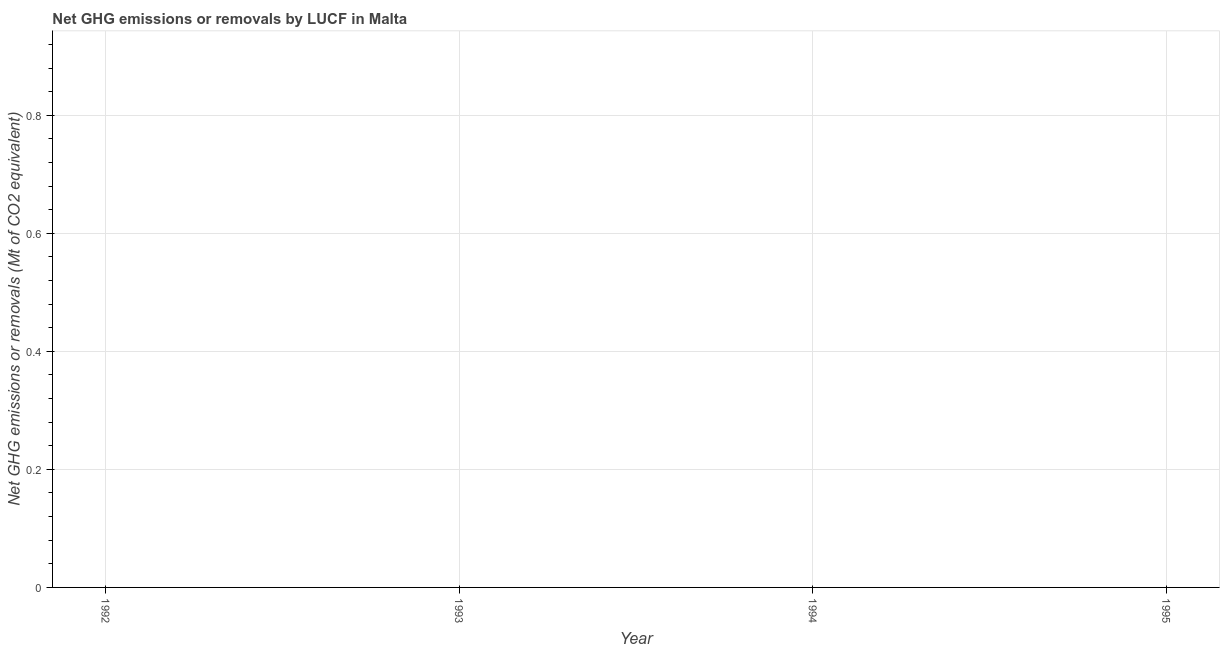What is the average ghg net emissions or removals per year?
Provide a short and direct response. 0. Are the values on the major ticks of Y-axis written in scientific E-notation?
Your answer should be very brief. No. Does the graph contain any zero values?
Offer a terse response. Yes. Does the graph contain grids?
Make the answer very short. Yes. What is the title of the graph?
Keep it short and to the point. Net GHG emissions or removals by LUCF in Malta. What is the label or title of the Y-axis?
Offer a very short reply. Net GHG emissions or removals (Mt of CO2 equivalent). What is the Net GHG emissions or removals (Mt of CO2 equivalent) in 1994?
Give a very brief answer. 0. What is the Net GHG emissions or removals (Mt of CO2 equivalent) in 1995?
Ensure brevity in your answer.  0. 